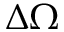Convert formula to latex. <formula><loc_0><loc_0><loc_500><loc_500>\Delta \Omega</formula> 